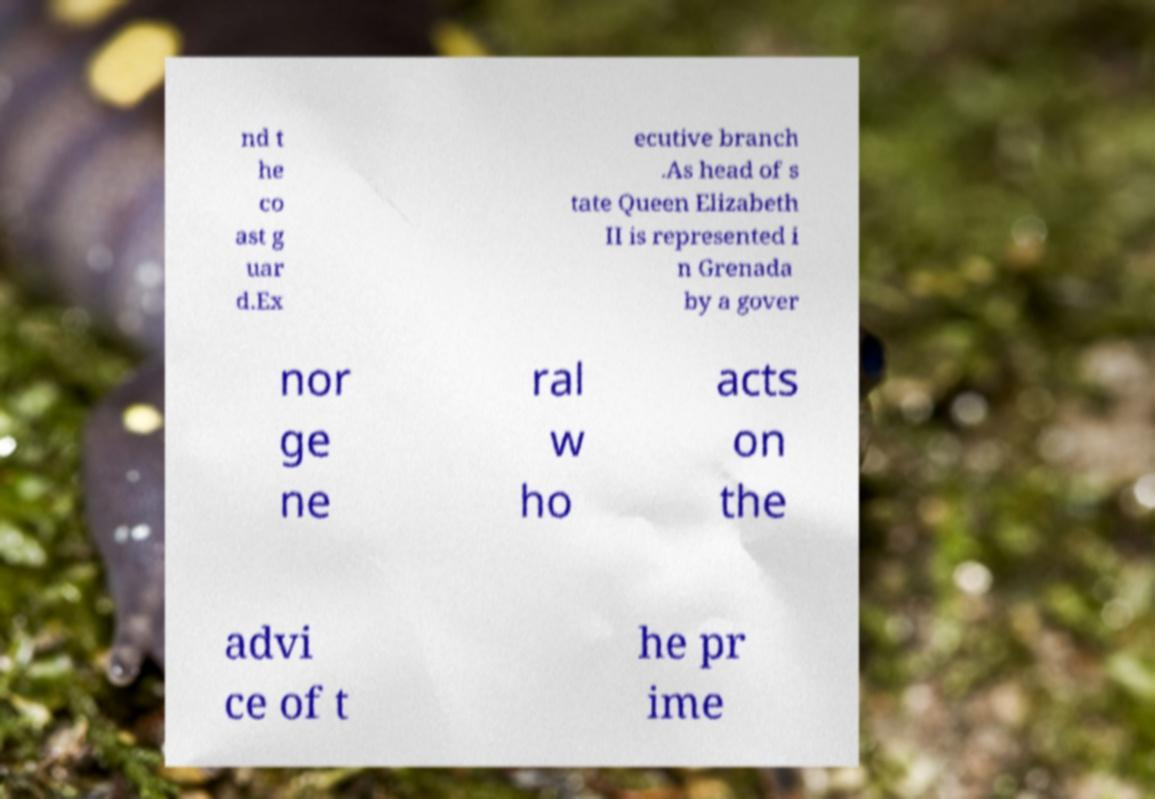For documentation purposes, I need the text within this image transcribed. Could you provide that? nd t he co ast g uar d.Ex ecutive branch .As head of s tate Queen Elizabeth II is represented i n Grenada by a gover nor ge ne ral w ho acts on the advi ce of t he pr ime 